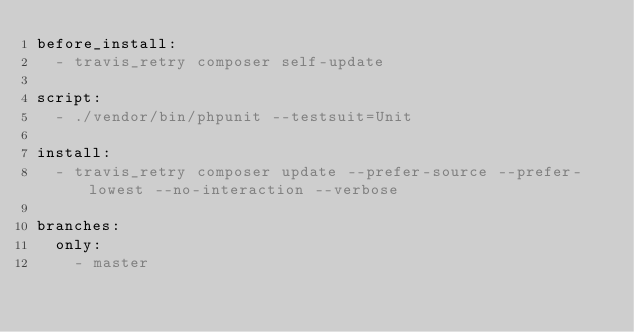<code> <loc_0><loc_0><loc_500><loc_500><_YAML_>before_install:
  - travis_retry composer self-update

script:
  - ./vendor/bin/phpunit --testsuit=Unit

install:
  - travis_retry composer update --prefer-source --prefer-lowest --no-interaction --verbose

branches:
  only:
    - master
</code> 